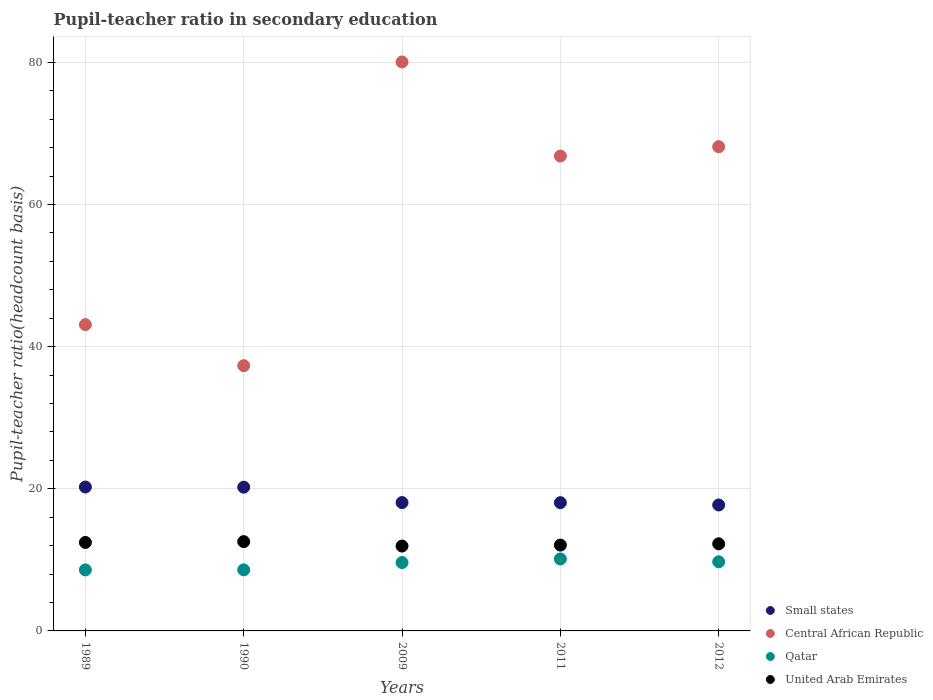How many different coloured dotlines are there?
Your answer should be compact. 4. What is the pupil-teacher ratio in secondary education in Qatar in 2011?
Ensure brevity in your answer.  10.13. Across all years, what is the maximum pupil-teacher ratio in secondary education in Qatar?
Your response must be concise. 10.13. Across all years, what is the minimum pupil-teacher ratio in secondary education in Qatar?
Offer a very short reply. 8.59. In which year was the pupil-teacher ratio in secondary education in Qatar maximum?
Keep it short and to the point. 2011. In which year was the pupil-teacher ratio in secondary education in Small states minimum?
Your response must be concise. 2012. What is the total pupil-teacher ratio in secondary education in Qatar in the graph?
Offer a very short reply. 46.65. What is the difference between the pupil-teacher ratio in secondary education in United Arab Emirates in 1989 and that in 2012?
Your response must be concise. 0.19. What is the difference between the pupil-teacher ratio in secondary education in United Arab Emirates in 1990 and the pupil-teacher ratio in secondary education in Central African Republic in 2009?
Ensure brevity in your answer.  -67.49. What is the average pupil-teacher ratio in secondary education in United Arab Emirates per year?
Offer a terse response. 12.26. In the year 2011, what is the difference between the pupil-teacher ratio in secondary education in Central African Republic and pupil-teacher ratio in secondary education in United Arab Emirates?
Your response must be concise. 54.74. What is the ratio of the pupil-teacher ratio in secondary education in Central African Republic in 1990 to that in 2012?
Offer a terse response. 0.55. Is the pupil-teacher ratio in secondary education in Qatar in 2011 less than that in 2012?
Make the answer very short. No. What is the difference between the highest and the second highest pupil-teacher ratio in secondary education in United Arab Emirates?
Offer a terse response. 0.12. What is the difference between the highest and the lowest pupil-teacher ratio in secondary education in Small states?
Offer a terse response. 2.53. Is the sum of the pupil-teacher ratio in secondary education in Small states in 2011 and 2012 greater than the maximum pupil-teacher ratio in secondary education in Central African Republic across all years?
Your answer should be compact. No. Does the pupil-teacher ratio in secondary education in Qatar monotonically increase over the years?
Give a very brief answer. No. How many dotlines are there?
Your response must be concise. 4. Where does the legend appear in the graph?
Your answer should be very brief. Bottom right. What is the title of the graph?
Your response must be concise. Pupil-teacher ratio in secondary education. What is the label or title of the X-axis?
Offer a very short reply. Years. What is the label or title of the Y-axis?
Offer a very short reply. Pupil-teacher ratio(headcount basis). What is the Pupil-teacher ratio(headcount basis) in Small states in 1989?
Provide a short and direct response. 20.25. What is the Pupil-teacher ratio(headcount basis) in Central African Republic in 1989?
Your answer should be very brief. 43.1. What is the Pupil-teacher ratio(headcount basis) of Qatar in 1989?
Provide a short and direct response. 8.59. What is the Pupil-teacher ratio(headcount basis) of United Arab Emirates in 1989?
Your answer should be compact. 12.45. What is the Pupil-teacher ratio(headcount basis) in Small states in 1990?
Offer a very short reply. 20.22. What is the Pupil-teacher ratio(headcount basis) in Central African Republic in 1990?
Offer a very short reply. 37.32. What is the Pupil-teacher ratio(headcount basis) in Qatar in 1990?
Your answer should be compact. 8.59. What is the Pupil-teacher ratio(headcount basis) in United Arab Emirates in 1990?
Your answer should be very brief. 12.56. What is the Pupil-teacher ratio(headcount basis) of Small states in 2009?
Your answer should be very brief. 18.06. What is the Pupil-teacher ratio(headcount basis) of Central African Republic in 2009?
Your response must be concise. 80.05. What is the Pupil-teacher ratio(headcount basis) of Qatar in 2009?
Keep it short and to the point. 9.62. What is the Pupil-teacher ratio(headcount basis) of United Arab Emirates in 2009?
Give a very brief answer. 11.94. What is the Pupil-teacher ratio(headcount basis) of Small states in 2011?
Your answer should be compact. 18.05. What is the Pupil-teacher ratio(headcount basis) in Central African Republic in 2011?
Your response must be concise. 66.82. What is the Pupil-teacher ratio(headcount basis) of Qatar in 2011?
Offer a very short reply. 10.13. What is the Pupil-teacher ratio(headcount basis) of United Arab Emirates in 2011?
Your response must be concise. 12.08. What is the Pupil-teacher ratio(headcount basis) in Small states in 2012?
Your answer should be compact. 17.72. What is the Pupil-teacher ratio(headcount basis) in Central African Republic in 2012?
Your answer should be compact. 68.13. What is the Pupil-teacher ratio(headcount basis) in Qatar in 2012?
Offer a terse response. 9.73. What is the Pupil-teacher ratio(headcount basis) in United Arab Emirates in 2012?
Offer a very short reply. 12.26. Across all years, what is the maximum Pupil-teacher ratio(headcount basis) in Small states?
Your answer should be very brief. 20.25. Across all years, what is the maximum Pupil-teacher ratio(headcount basis) in Central African Republic?
Make the answer very short. 80.05. Across all years, what is the maximum Pupil-teacher ratio(headcount basis) of Qatar?
Offer a very short reply. 10.13. Across all years, what is the maximum Pupil-teacher ratio(headcount basis) in United Arab Emirates?
Your answer should be compact. 12.56. Across all years, what is the minimum Pupil-teacher ratio(headcount basis) of Small states?
Your response must be concise. 17.72. Across all years, what is the minimum Pupil-teacher ratio(headcount basis) in Central African Republic?
Offer a very short reply. 37.32. Across all years, what is the minimum Pupil-teacher ratio(headcount basis) in Qatar?
Your answer should be very brief. 8.59. Across all years, what is the minimum Pupil-teacher ratio(headcount basis) in United Arab Emirates?
Provide a short and direct response. 11.94. What is the total Pupil-teacher ratio(headcount basis) in Small states in the graph?
Offer a very short reply. 94.3. What is the total Pupil-teacher ratio(headcount basis) in Central African Republic in the graph?
Ensure brevity in your answer.  295.42. What is the total Pupil-teacher ratio(headcount basis) in Qatar in the graph?
Provide a succinct answer. 46.65. What is the total Pupil-teacher ratio(headcount basis) of United Arab Emirates in the graph?
Make the answer very short. 61.29. What is the difference between the Pupil-teacher ratio(headcount basis) of Small states in 1989 and that in 1990?
Make the answer very short. 0.02. What is the difference between the Pupil-teacher ratio(headcount basis) in Central African Republic in 1989 and that in 1990?
Your response must be concise. 5.78. What is the difference between the Pupil-teacher ratio(headcount basis) of Qatar in 1989 and that in 1990?
Keep it short and to the point. -0.01. What is the difference between the Pupil-teacher ratio(headcount basis) of United Arab Emirates in 1989 and that in 1990?
Your answer should be very brief. -0.12. What is the difference between the Pupil-teacher ratio(headcount basis) in Small states in 1989 and that in 2009?
Offer a terse response. 2.19. What is the difference between the Pupil-teacher ratio(headcount basis) in Central African Republic in 1989 and that in 2009?
Ensure brevity in your answer.  -36.95. What is the difference between the Pupil-teacher ratio(headcount basis) in Qatar in 1989 and that in 2009?
Your response must be concise. -1.03. What is the difference between the Pupil-teacher ratio(headcount basis) in United Arab Emirates in 1989 and that in 2009?
Offer a terse response. 0.51. What is the difference between the Pupil-teacher ratio(headcount basis) in Small states in 1989 and that in 2011?
Give a very brief answer. 2.2. What is the difference between the Pupil-teacher ratio(headcount basis) of Central African Republic in 1989 and that in 2011?
Provide a short and direct response. -23.72. What is the difference between the Pupil-teacher ratio(headcount basis) of Qatar in 1989 and that in 2011?
Your response must be concise. -1.54. What is the difference between the Pupil-teacher ratio(headcount basis) in United Arab Emirates in 1989 and that in 2011?
Your answer should be compact. 0.37. What is the difference between the Pupil-teacher ratio(headcount basis) of Small states in 1989 and that in 2012?
Your answer should be very brief. 2.53. What is the difference between the Pupil-teacher ratio(headcount basis) of Central African Republic in 1989 and that in 2012?
Ensure brevity in your answer.  -25.03. What is the difference between the Pupil-teacher ratio(headcount basis) of Qatar in 1989 and that in 2012?
Give a very brief answer. -1.14. What is the difference between the Pupil-teacher ratio(headcount basis) of United Arab Emirates in 1989 and that in 2012?
Your response must be concise. 0.19. What is the difference between the Pupil-teacher ratio(headcount basis) of Small states in 1990 and that in 2009?
Make the answer very short. 2.17. What is the difference between the Pupil-teacher ratio(headcount basis) of Central African Republic in 1990 and that in 2009?
Your answer should be compact. -42.73. What is the difference between the Pupil-teacher ratio(headcount basis) of Qatar in 1990 and that in 2009?
Your answer should be very brief. -1.02. What is the difference between the Pupil-teacher ratio(headcount basis) of United Arab Emirates in 1990 and that in 2009?
Give a very brief answer. 0.62. What is the difference between the Pupil-teacher ratio(headcount basis) in Small states in 1990 and that in 2011?
Your response must be concise. 2.18. What is the difference between the Pupil-teacher ratio(headcount basis) in Central African Republic in 1990 and that in 2011?
Your response must be concise. -29.5. What is the difference between the Pupil-teacher ratio(headcount basis) of Qatar in 1990 and that in 2011?
Offer a terse response. -1.53. What is the difference between the Pupil-teacher ratio(headcount basis) of United Arab Emirates in 1990 and that in 2011?
Ensure brevity in your answer.  0.49. What is the difference between the Pupil-teacher ratio(headcount basis) in Small states in 1990 and that in 2012?
Your answer should be very brief. 2.5. What is the difference between the Pupil-teacher ratio(headcount basis) in Central African Republic in 1990 and that in 2012?
Your answer should be compact. -30.81. What is the difference between the Pupil-teacher ratio(headcount basis) of Qatar in 1990 and that in 2012?
Your answer should be very brief. -1.13. What is the difference between the Pupil-teacher ratio(headcount basis) of United Arab Emirates in 1990 and that in 2012?
Your answer should be very brief. 0.31. What is the difference between the Pupil-teacher ratio(headcount basis) in Small states in 2009 and that in 2011?
Keep it short and to the point. 0.01. What is the difference between the Pupil-teacher ratio(headcount basis) in Central African Republic in 2009 and that in 2011?
Provide a short and direct response. 13.24. What is the difference between the Pupil-teacher ratio(headcount basis) in Qatar in 2009 and that in 2011?
Offer a terse response. -0.51. What is the difference between the Pupil-teacher ratio(headcount basis) of United Arab Emirates in 2009 and that in 2011?
Give a very brief answer. -0.14. What is the difference between the Pupil-teacher ratio(headcount basis) of Small states in 2009 and that in 2012?
Make the answer very short. 0.34. What is the difference between the Pupil-teacher ratio(headcount basis) in Central African Republic in 2009 and that in 2012?
Make the answer very short. 11.92. What is the difference between the Pupil-teacher ratio(headcount basis) of Qatar in 2009 and that in 2012?
Provide a short and direct response. -0.11. What is the difference between the Pupil-teacher ratio(headcount basis) of United Arab Emirates in 2009 and that in 2012?
Ensure brevity in your answer.  -0.32. What is the difference between the Pupil-teacher ratio(headcount basis) in Small states in 2011 and that in 2012?
Keep it short and to the point. 0.32. What is the difference between the Pupil-teacher ratio(headcount basis) in Central African Republic in 2011 and that in 2012?
Offer a very short reply. -1.31. What is the difference between the Pupil-teacher ratio(headcount basis) of Qatar in 2011 and that in 2012?
Provide a succinct answer. 0.4. What is the difference between the Pupil-teacher ratio(headcount basis) in United Arab Emirates in 2011 and that in 2012?
Make the answer very short. -0.18. What is the difference between the Pupil-teacher ratio(headcount basis) of Small states in 1989 and the Pupil-teacher ratio(headcount basis) of Central African Republic in 1990?
Your answer should be very brief. -17.07. What is the difference between the Pupil-teacher ratio(headcount basis) of Small states in 1989 and the Pupil-teacher ratio(headcount basis) of Qatar in 1990?
Offer a very short reply. 11.65. What is the difference between the Pupil-teacher ratio(headcount basis) in Small states in 1989 and the Pupil-teacher ratio(headcount basis) in United Arab Emirates in 1990?
Your response must be concise. 7.68. What is the difference between the Pupil-teacher ratio(headcount basis) of Central African Republic in 1989 and the Pupil-teacher ratio(headcount basis) of Qatar in 1990?
Offer a terse response. 34.51. What is the difference between the Pupil-teacher ratio(headcount basis) in Central African Republic in 1989 and the Pupil-teacher ratio(headcount basis) in United Arab Emirates in 1990?
Offer a terse response. 30.53. What is the difference between the Pupil-teacher ratio(headcount basis) in Qatar in 1989 and the Pupil-teacher ratio(headcount basis) in United Arab Emirates in 1990?
Offer a terse response. -3.98. What is the difference between the Pupil-teacher ratio(headcount basis) in Small states in 1989 and the Pupil-teacher ratio(headcount basis) in Central African Republic in 2009?
Your response must be concise. -59.8. What is the difference between the Pupil-teacher ratio(headcount basis) of Small states in 1989 and the Pupil-teacher ratio(headcount basis) of Qatar in 2009?
Offer a terse response. 10.63. What is the difference between the Pupil-teacher ratio(headcount basis) in Small states in 1989 and the Pupil-teacher ratio(headcount basis) in United Arab Emirates in 2009?
Ensure brevity in your answer.  8.31. What is the difference between the Pupil-teacher ratio(headcount basis) of Central African Republic in 1989 and the Pupil-teacher ratio(headcount basis) of Qatar in 2009?
Offer a very short reply. 33.48. What is the difference between the Pupil-teacher ratio(headcount basis) in Central African Republic in 1989 and the Pupil-teacher ratio(headcount basis) in United Arab Emirates in 2009?
Provide a succinct answer. 31.16. What is the difference between the Pupil-teacher ratio(headcount basis) in Qatar in 1989 and the Pupil-teacher ratio(headcount basis) in United Arab Emirates in 2009?
Provide a short and direct response. -3.36. What is the difference between the Pupil-teacher ratio(headcount basis) of Small states in 1989 and the Pupil-teacher ratio(headcount basis) of Central African Republic in 2011?
Your response must be concise. -46.57. What is the difference between the Pupil-teacher ratio(headcount basis) of Small states in 1989 and the Pupil-teacher ratio(headcount basis) of Qatar in 2011?
Offer a very short reply. 10.12. What is the difference between the Pupil-teacher ratio(headcount basis) of Small states in 1989 and the Pupil-teacher ratio(headcount basis) of United Arab Emirates in 2011?
Offer a terse response. 8.17. What is the difference between the Pupil-teacher ratio(headcount basis) in Central African Republic in 1989 and the Pupil-teacher ratio(headcount basis) in Qatar in 2011?
Keep it short and to the point. 32.97. What is the difference between the Pupil-teacher ratio(headcount basis) of Central African Republic in 1989 and the Pupil-teacher ratio(headcount basis) of United Arab Emirates in 2011?
Provide a succinct answer. 31.02. What is the difference between the Pupil-teacher ratio(headcount basis) of Qatar in 1989 and the Pupil-teacher ratio(headcount basis) of United Arab Emirates in 2011?
Ensure brevity in your answer.  -3.49. What is the difference between the Pupil-teacher ratio(headcount basis) in Small states in 1989 and the Pupil-teacher ratio(headcount basis) in Central African Republic in 2012?
Give a very brief answer. -47.88. What is the difference between the Pupil-teacher ratio(headcount basis) of Small states in 1989 and the Pupil-teacher ratio(headcount basis) of Qatar in 2012?
Keep it short and to the point. 10.52. What is the difference between the Pupil-teacher ratio(headcount basis) in Small states in 1989 and the Pupil-teacher ratio(headcount basis) in United Arab Emirates in 2012?
Keep it short and to the point. 7.99. What is the difference between the Pupil-teacher ratio(headcount basis) in Central African Republic in 1989 and the Pupil-teacher ratio(headcount basis) in Qatar in 2012?
Your response must be concise. 33.37. What is the difference between the Pupil-teacher ratio(headcount basis) of Central African Republic in 1989 and the Pupil-teacher ratio(headcount basis) of United Arab Emirates in 2012?
Provide a short and direct response. 30.84. What is the difference between the Pupil-teacher ratio(headcount basis) of Qatar in 1989 and the Pupil-teacher ratio(headcount basis) of United Arab Emirates in 2012?
Your response must be concise. -3.67. What is the difference between the Pupil-teacher ratio(headcount basis) in Small states in 1990 and the Pupil-teacher ratio(headcount basis) in Central African Republic in 2009?
Offer a terse response. -59.83. What is the difference between the Pupil-teacher ratio(headcount basis) in Small states in 1990 and the Pupil-teacher ratio(headcount basis) in Qatar in 2009?
Provide a short and direct response. 10.61. What is the difference between the Pupil-teacher ratio(headcount basis) in Small states in 1990 and the Pupil-teacher ratio(headcount basis) in United Arab Emirates in 2009?
Your answer should be compact. 8.28. What is the difference between the Pupil-teacher ratio(headcount basis) of Central African Republic in 1990 and the Pupil-teacher ratio(headcount basis) of Qatar in 2009?
Provide a succinct answer. 27.7. What is the difference between the Pupil-teacher ratio(headcount basis) in Central African Republic in 1990 and the Pupil-teacher ratio(headcount basis) in United Arab Emirates in 2009?
Your answer should be very brief. 25.38. What is the difference between the Pupil-teacher ratio(headcount basis) in Qatar in 1990 and the Pupil-teacher ratio(headcount basis) in United Arab Emirates in 2009?
Ensure brevity in your answer.  -3.35. What is the difference between the Pupil-teacher ratio(headcount basis) of Small states in 1990 and the Pupil-teacher ratio(headcount basis) of Central African Republic in 2011?
Keep it short and to the point. -46.59. What is the difference between the Pupil-teacher ratio(headcount basis) of Small states in 1990 and the Pupil-teacher ratio(headcount basis) of Qatar in 2011?
Your response must be concise. 10.1. What is the difference between the Pupil-teacher ratio(headcount basis) of Small states in 1990 and the Pupil-teacher ratio(headcount basis) of United Arab Emirates in 2011?
Provide a short and direct response. 8.15. What is the difference between the Pupil-teacher ratio(headcount basis) of Central African Republic in 1990 and the Pupil-teacher ratio(headcount basis) of Qatar in 2011?
Give a very brief answer. 27.19. What is the difference between the Pupil-teacher ratio(headcount basis) in Central African Republic in 1990 and the Pupil-teacher ratio(headcount basis) in United Arab Emirates in 2011?
Provide a short and direct response. 25.24. What is the difference between the Pupil-teacher ratio(headcount basis) of Qatar in 1990 and the Pupil-teacher ratio(headcount basis) of United Arab Emirates in 2011?
Give a very brief answer. -3.48. What is the difference between the Pupil-teacher ratio(headcount basis) in Small states in 1990 and the Pupil-teacher ratio(headcount basis) in Central African Republic in 2012?
Ensure brevity in your answer.  -47.91. What is the difference between the Pupil-teacher ratio(headcount basis) in Small states in 1990 and the Pupil-teacher ratio(headcount basis) in Qatar in 2012?
Provide a short and direct response. 10.5. What is the difference between the Pupil-teacher ratio(headcount basis) of Small states in 1990 and the Pupil-teacher ratio(headcount basis) of United Arab Emirates in 2012?
Provide a short and direct response. 7.97. What is the difference between the Pupil-teacher ratio(headcount basis) in Central African Republic in 1990 and the Pupil-teacher ratio(headcount basis) in Qatar in 2012?
Your answer should be compact. 27.59. What is the difference between the Pupil-teacher ratio(headcount basis) in Central African Republic in 1990 and the Pupil-teacher ratio(headcount basis) in United Arab Emirates in 2012?
Provide a short and direct response. 25.06. What is the difference between the Pupil-teacher ratio(headcount basis) in Qatar in 1990 and the Pupil-teacher ratio(headcount basis) in United Arab Emirates in 2012?
Provide a succinct answer. -3.66. What is the difference between the Pupil-teacher ratio(headcount basis) of Small states in 2009 and the Pupil-teacher ratio(headcount basis) of Central African Republic in 2011?
Offer a terse response. -48.76. What is the difference between the Pupil-teacher ratio(headcount basis) of Small states in 2009 and the Pupil-teacher ratio(headcount basis) of Qatar in 2011?
Your answer should be compact. 7.93. What is the difference between the Pupil-teacher ratio(headcount basis) in Small states in 2009 and the Pupil-teacher ratio(headcount basis) in United Arab Emirates in 2011?
Your response must be concise. 5.98. What is the difference between the Pupil-teacher ratio(headcount basis) in Central African Republic in 2009 and the Pupil-teacher ratio(headcount basis) in Qatar in 2011?
Your response must be concise. 69.93. What is the difference between the Pupil-teacher ratio(headcount basis) in Central African Republic in 2009 and the Pupil-teacher ratio(headcount basis) in United Arab Emirates in 2011?
Provide a short and direct response. 67.98. What is the difference between the Pupil-teacher ratio(headcount basis) in Qatar in 2009 and the Pupil-teacher ratio(headcount basis) in United Arab Emirates in 2011?
Give a very brief answer. -2.46. What is the difference between the Pupil-teacher ratio(headcount basis) in Small states in 2009 and the Pupil-teacher ratio(headcount basis) in Central African Republic in 2012?
Your response must be concise. -50.07. What is the difference between the Pupil-teacher ratio(headcount basis) of Small states in 2009 and the Pupil-teacher ratio(headcount basis) of Qatar in 2012?
Your answer should be very brief. 8.33. What is the difference between the Pupil-teacher ratio(headcount basis) in Small states in 2009 and the Pupil-teacher ratio(headcount basis) in United Arab Emirates in 2012?
Your response must be concise. 5.8. What is the difference between the Pupil-teacher ratio(headcount basis) in Central African Republic in 2009 and the Pupil-teacher ratio(headcount basis) in Qatar in 2012?
Provide a short and direct response. 70.32. What is the difference between the Pupil-teacher ratio(headcount basis) of Central African Republic in 2009 and the Pupil-teacher ratio(headcount basis) of United Arab Emirates in 2012?
Make the answer very short. 67.79. What is the difference between the Pupil-teacher ratio(headcount basis) of Qatar in 2009 and the Pupil-teacher ratio(headcount basis) of United Arab Emirates in 2012?
Ensure brevity in your answer.  -2.64. What is the difference between the Pupil-teacher ratio(headcount basis) of Small states in 2011 and the Pupil-teacher ratio(headcount basis) of Central African Republic in 2012?
Offer a very short reply. -50.09. What is the difference between the Pupil-teacher ratio(headcount basis) in Small states in 2011 and the Pupil-teacher ratio(headcount basis) in Qatar in 2012?
Your answer should be very brief. 8.32. What is the difference between the Pupil-teacher ratio(headcount basis) of Small states in 2011 and the Pupil-teacher ratio(headcount basis) of United Arab Emirates in 2012?
Provide a succinct answer. 5.79. What is the difference between the Pupil-teacher ratio(headcount basis) in Central African Republic in 2011 and the Pupil-teacher ratio(headcount basis) in Qatar in 2012?
Your response must be concise. 57.09. What is the difference between the Pupil-teacher ratio(headcount basis) in Central African Republic in 2011 and the Pupil-teacher ratio(headcount basis) in United Arab Emirates in 2012?
Ensure brevity in your answer.  54.56. What is the difference between the Pupil-teacher ratio(headcount basis) in Qatar in 2011 and the Pupil-teacher ratio(headcount basis) in United Arab Emirates in 2012?
Keep it short and to the point. -2.13. What is the average Pupil-teacher ratio(headcount basis) of Small states per year?
Keep it short and to the point. 18.86. What is the average Pupil-teacher ratio(headcount basis) in Central African Republic per year?
Offer a terse response. 59.08. What is the average Pupil-teacher ratio(headcount basis) of Qatar per year?
Offer a terse response. 9.33. What is the average Pupil-teacher ratio(headcount basis) of United Arab Emirates per year?
Offer a terse response. 12.26. In the year 1989, what is the difference between the Pupil-teacher ratio(headcount basis) of Small states and Pupil-teacher ratio(headcount basis) of Central African Republic?
Provide a short and direct response. -22.85. In the year 1989, what is the difference between the Pupil-teacher ratio(headcount basis) in Small states and Pupil-teacher ratio(headcount basis) in Qatar?
Provide a short and direct response. 11.66. In the year 1989, what is the difference between the Pupil-teacher ratio(headcount basis) in Small states and Pupil-teacher ratio(headcount basis) in United Arab Emirates?
Keep it short and to the point. 7.8. In the year 1989, what is the difference between the Pupil-teacher ratio(headcount basis) in Central African Republic and Pupil-teacher ratio(headcount basis) in Qatar?
Make the answer very short. 34.51. In the year 1989, what is the difference between the Pupil-teacher ratio(headcount basis) in Central African Republic and Pupil-teacher ratio(headcount basis) in United Arab Emirates?
Your response must be concise. 30.65. In the year 1989, what is the difference between the Pupil-teacher ratio(headcount basis) of Qatar and Pupil-teacher ratio(headcount basis) of United Arab Emirates?
Provide a short and direct response. -3.86. In the year 1990, what is the difference between the Pupil-teacher ratio(headcount basis) in Small states and Pupil-teacher ratio(headcount basis) in Central African Republic?
Offer a terse response. -17.09. In the year 1990, what is the difference between the Pupil-teacher ratio(headcount basis) of Small states and Pupil-teacher ratio(headcount basis) of Qatar?
Offer a terse response. 11.63. In the year 1990, what is the difference between the Pupil-teacher ratio(headcount basis) in Small states and Pupil-teacher ratio(headcount basis) in United Arab Emirates?
Provide a succinct answer. 7.66. In the year 1990, what is the difference between the Pupil-teacher ratio(headcount basis) in Central African Republic and Pupil-teacher ratio(headcount basis) in Qatar?
Your answer should be compact. 28.72. In the year 1990, what is the difference between the Pupil-teacher ratio(headcount basis) in Central African Republic and Pupil-teacher ratio(headcount basis) in United Arab Emirates?
Offer a terse response. 24.75. In the year 1990, what is the difference between the Pupil-teacher ratio(headcount basis) in Qatar and Pupil-teacher ratio(headcount basis) in United Arab Emirates?
Offer a terse response. -3.97. In the year 2009, what is the difference between the Pupil-teacher ratio(headcount basis) of Small states and Pupil-teacher ratio(headcount basis) of Central African Republic?
Keep it short and to the point. -61.99. In the year 2009, what is the difference between the Pupil-teacher ratio(headcount basis) of Small states and Pupil-teacher ratio(headcount basis) of Qatar?
Keep it short and to the point. 8.44. In the year 2009, what is the difference between the Pupil-teacher ratio(headcount basis) in Small states and Pupil-teacher ratio(headcount basis) in United Arab Emirates?
Offer a terse response. 6.12. In the year 2009, what is the difference between the Pupil-teacher ratio(headcount basis) of Central African Republic and Pupil-teacher ratio(headcount basis) of Qatar?
Your answer should be very brief. 70.43. In the year 2009, what is the difference between the Pupil-teacher ratio(headcount basis) of Central African Republic and Pupil-teacher ratio(headcount basis) of United Arab Emirates?
Ensure brevity in your answer.  68.11. In the year 2009, what is the difference between the Pupil-teacher ratio(headcount basis) in Qatar and Pupil-teacher ratio(headcount basis) in United Arab Emirates?
Offer a very short reply. -2.32. In the year 2011, what is the difference between the Pupil-teacher ratio(headcount basis) of Small states and Pupil-teacher ratio(headcount basis) of Central African Republic?
Provide a short and direct response. -48.77. In the year 2011, what is the difference between the Pupil-teacher ratio(headcount basis) of Small states and Pupil-teacher ratio(headcount basis) of Qatar?
Your response must be concise. 7.92. In the year 2011, what is the difference between the Pupil-teacher ratio(headcount basis) of Small states and Pupil-teacher ratio(headcount basis) of United Arab Emirates?
Give a very brief answer. 5.97. In the year 2011, what is the difference between the Pupil-teacher ratio(headcount basis) in Central African Republic and Pupil-teacher ratio(headcount basis) in Qatar?
Provide a succinct answer. 56.69. In the year 2011, what is the difference between the Pupil-teacher ratio(headcount basis) of Central African Republic and Pupil-teacher ratio(headcount basis) of United Arab Emirates?
Provide a succinct answer. 54.74. In the year 2011, what is the difference between the Pupil-teacher ratio(headcount basis) in Qatar and Pupil-teacher ratio(headcount basis) in United Arab Emirates?
Give a very brief answer. -1.95. In the year 2012, what is the difference between the Pupil-teacher ratio(headcount basis) of Small states and Pupil-teacher ratio(headcount basis) of Central African Republic?
Offer a very short reply. -50.41. In the year 2012, what is the difference between the Pupil-teacher ratio(headcount basis) in Small states and Pupil-teacher ratio(headcount basis) in Qatar?
Provide a succinct answer. 7.99. In the year 2012, what is the difference between the Pupil-teacher ratio(headcount basis) of Small states and Pupil-teacher ratio(headcount basis) of United Arab Emirates?
Offer a very short reply. 5.46. In the year 2012, what is the difference between the Pupil-teacher ratio(headcount basis) of Central African Republic and Pupil-teacher ratio(headcount basis) of Qatar?
Keep it short and to the point. 58.4. In the year 2012, what is the difference between the Pupil-teacher ratio(headcount basis) of Central African Republic and Pupil-teacher ratio(headcount basis) of United Arab Emirates?
Ensure brevity in your answer.  55.87. In the year 2012, what is the difference between the Pupil-teacher ratio(headcount basis) of Qatar and Pupil-teacher ratio(headcount basis) of United Arab Emirates?
Offer a terse response. -2.53. What is the ratio of the Pupil-teacher ratio(headcount basis) of Small states in 1989 to that in 1990?
Offer a terse response. 1. What is the ratio of the Pupil-teacher ratio(headcount basis) in Central African Republic in 1989 to that in 1990?
Provide a short and direct response. 1.15. What is the ratio of the Pupil-teacher ratio(headcount basis) in Qatar in 1989 to that in 1990?
Your response must be concise. 1. What is the ratio of the Pupil-teacher ratio(headcount basis) of United Arab Emirates in 1989 to that in 1990?
Your answer should be compact. 0.99. What is the ratio of the Pupil-teacher ratio(headcount basis) of Small states in 1989 to that in 2009?
Your answer should be compact. 1.12. What is the ratio of the Pupil-teacher ratio(headcount basis) in Central African Republic in 1989 to that in 2009?
Keep it short and to the point. 0.54. What is the ratio of the Pupil-teacher ratio(headcount basis) of Qatar in 1989 to that in 2009?
Keep it short and to the point. 0.89. What is the ratio of the Pupil-teacher ratio(headcount basis) of United Arab Emirates in 1989 to that in 2009?
Provide a short and direct response. 1.04. What is the ratio of the Pupil-teacher ratio(headcount basis) of Small states in 1989 to that in 2011?
Offer a terse response. 1.12. What is the ratio of the Pupil-teacher ratio(headcount basis) of Central African Republic in 1989 to that in 2011?
Provide a short and direct response. 0.65. What is the ratio of the Pupil-teacher ratio(headcount basis) of Qatar in 1989 to that in 2011?
Make the answer very short. 0.85. What is the ratio of the Pupil-teacher ratio(headcount basis) of United Arab Emirates in 1989 to that in 2011?
Provide a succinct answer. 1.03. What is the ratio of the Pupil-teacher ratio(headcount basis) of Small states in 1989 to that in 2012?
Provide a short and direct response. 1.14. What is the ratio of the Pupil-teacher ratio(headcount basis) in Central African Republic in 1989 to that in 2012?
Give a very brief answer. 0.63. What is the ratio of the Pupil-teacher ratio(headcount basis) of Qatar in 1989 to that in 2012?
Give a very brief answer. 0.88. What is the ratio of the Pupil-teacher ratio(headcount basis) in United Arab Emirates in 1989 to that in 2012?
Your response must be concise. 1.02. What is the ratio of the Pupil-teacher ratio(headcount basis) in Small states in 1990 to that in 2009?
Your answer should be compact. 1.12. What is the ratio of the Pupil-teacher ratio(headcount basis) in Central African Republic in 1990 to that in 2009?
Give a very brief answer. 0.47. What is the ratio of the Pupil-teacher ratio(headcount basis) of Qatar in 1990 to that in 2009?
Ensure brevity in your answer.  0.89. What is the ratio of the Pupil-teacher ratio(headcount basis) in United Arab Emirates in 1990 to that in 2009?
Keep it short and to the point. 1.05. What is the ratio of the Pupil-teacher ratio(headcount basis) in Small states in 1990 to that in 2011?
Your answer should be compact. 1.12. What is the ratio of the Pupil-teacher ratio(headcount basis) in Central African Republic in 1990 to that in 2011?
Provide a succinct answer. 0.56. What is the ratio of the Pupil-teacher ratio(headcount basis) in Qatar in 1990 to that in 2011?
Ensure brevity in your answer.  0.85. What is the ratio of the Pupil-teacher ratio(headcount basis) of United Arab Emirates in 1990 to that in 2011?
Give a very brief answer. 1.04. What is the ratio of the Pupil-teacher ratio(headcount basis) of Small states in 1990 to that in 2012?
Keep it short and to the point. 1.14. What is the ratio of the Pupil-teacher ratio(headcount basis) of Central African Republic in 1990 to that in 2012?
Make the answer very short. 0.55. What is the ratio of the Pupil-teacher ratio(headcount basis) of Qatar in 1990 to that in 2012?
Provide a short and direct response. 0.88. What is the ratio of the Pupil-teacher ratio(headcount basis) of United Arab Emirates in 1990 to that in 2012?
Ensure brevity in your answer.  1.02. What is the ratio of the Pupil-teacher ratio(headcount basis) in Central African Republic in 2009 to that in 2011?
Your answer should be compact. 1.2. What is the ratio of the Pupil-teacher ratio(headcount basis) of Qatar in 2009 to that in 2011?
Provide a short and direct response. 0.95. What is the ratio of the Pupil-teacher ratio(headcount basis) in Small states in 2009 to that in 2012?
Make the answer very short. 1.02. What is the ratio of the Pupil-teacher ratio(headcount basis) in Central African Republic in 2009 to that in 2012?
Offer a terse response. 1.18. What is the ratio of the Pupil-teacher ratio(headcount basis) of Qatar in 2009 to that in 2012?
Offer a terse response. 0.99. What is the ratio of the Pupil-teacher ratio(headcount basis) of United Arab Emirates in 2009 to that in 2012?
Keep it short and to the point. 0.97. What is the ratio of the Pupil-teacher ratio(headcount basis) of Small states in 2011 to that in 2012?
Ensure brevity in your answer.  1.02. What is the ratio of the Pupil-teacher ratio(headcount basis) of Central African Republic in 2011 to that in 2012?
Make the answer very short. 0.98. What is the ratio of the Pupil-teacher ratio(headcount basis) of Qatar in 2011 to that in 2012?
Give a very brief answer. 1.04. What is the ratio of the Pupil-teacher ratio(headcount basis) of United Arab Emirates in 2011 to that in 2012?
Your answer should be compact. 0.99. What is the difference between the highest and the second highest Pupil-teacher ratio(headcount basis) in Small states?
Provide a succinct answer. 0.02. What is the difference between the highest and the second highest Pupil-teacher ratio(headcount basis) in Central African Republic?
Make the answer very short. 11.92. What is the difference between the highest and the second highest Pupil-teacher ratio(headcount basis) in Qatar?
Your response must be concise. 0.4. What is the difference between the highest and the second highest Pupil-teacher ratio(headcount basis) in United Arab Emirates?
Ensure brevity in your answer.  0.12. What is the difference between the highest and the lowest Pupil-teacher ratio(headcount basis) of Small states?
Offer a very short reply. 2.53. What is the difference between the highest and the lowest Pupil-teacher ratio(headcount basis) of Central African Republic?
Make the answer very short. 42.73. What is the difference between the highest and the lowest Pupil-teacher ratio(headcount basis) of Qatar?
Offer a terse response. 1.54. What is the difference between the highest and the lowest Pupil-teacher ratio(headcount basis) of United Arab Emirates?
Your response must be concise. 0.62. 